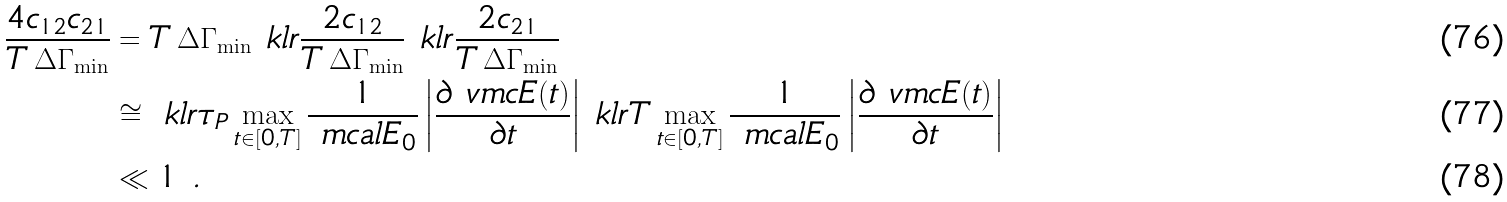<formula> <loc_0><loc_0><loc_500><loc_500>\frac { 4 c _ { 1 2 } c _ { 2 1 } } { T \, \Delta \Gamma _ { \min } } & = T \, \Delta \Gamma _ { \min } \ k l r { \frac { 2 c _ { 1 2 } } { T \, \Delta \Gamma _ { \min } } } \ k l r { \frac { 2 c _ { 2 1 } } { T \, \Delta \Gamma _ { \min } } } \\ & \cong \ k l r { \tau _ { P } \max _ { t \in [ 0 , T ] } \frac { 1 } { \ m c a l E _ { 0 } } \left | \frac { \partial \ v m c E ( t ) } { \partial t } \right | } \ k l r { T \max _ { t \in [ 0 , T ] } \frac { 1 } { \ m c a l E _ { 0 } } \left | \frac { \partial \ v m c E ( t ) } { \partial t } \right | } \\ & \ll 1 \ .</formula> 